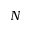<formula> <loc_0><loc_0><loc_500><loc_500>N</formula> 